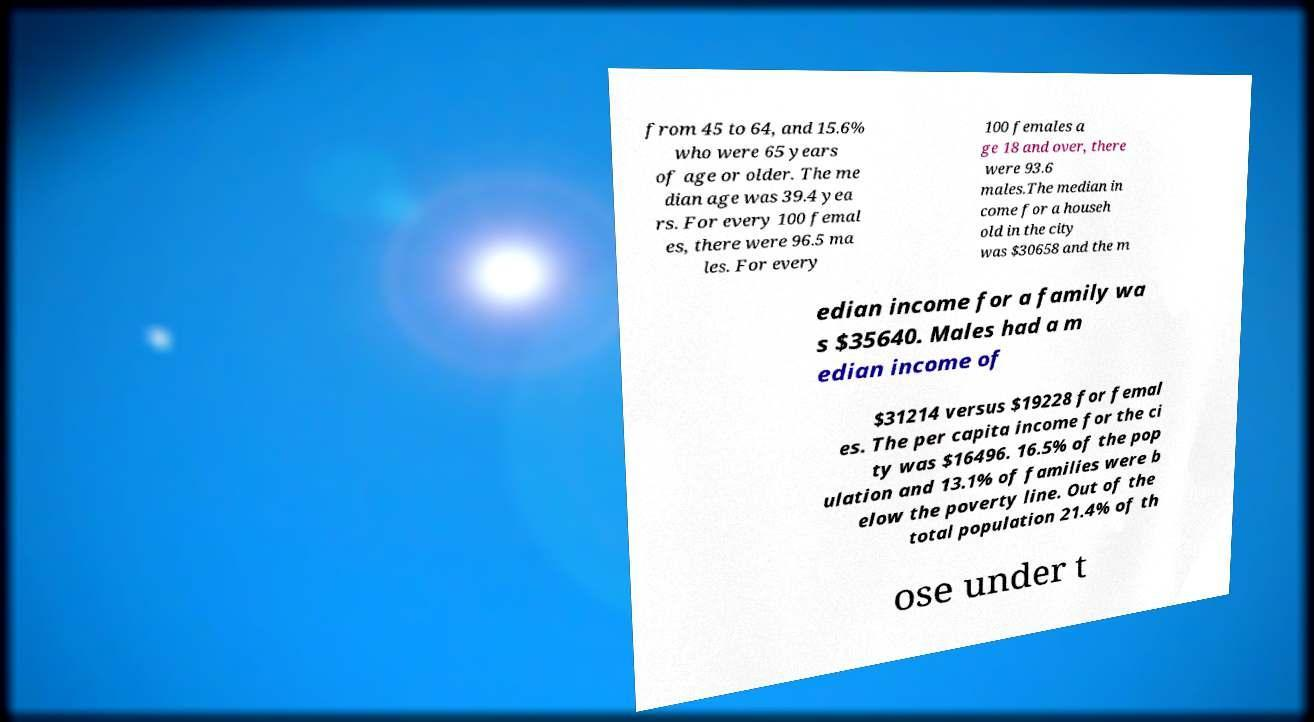There's text embedded in this image that I need extracted. Can you transcribe it verbatim? from 45 to 64, and 15.6% who were 65 years of age or older. The me dian age was 39.4 yea rs. For every 100 femal es, there were 96.5 ma les. For every 100 females a ge 18 and over, there were 93.6 males.The median in come for a househ old in the city was $30658 and the m edian income for a family wa s $35640. Males had a m edian income of $31214 versus $19228 for femal es. The per capita income for the ci ty was $16496. 16.5% of the pop ulation and 13.1% of families were b elow the poverty line. Out of the total population 21.4% of th ose under t 